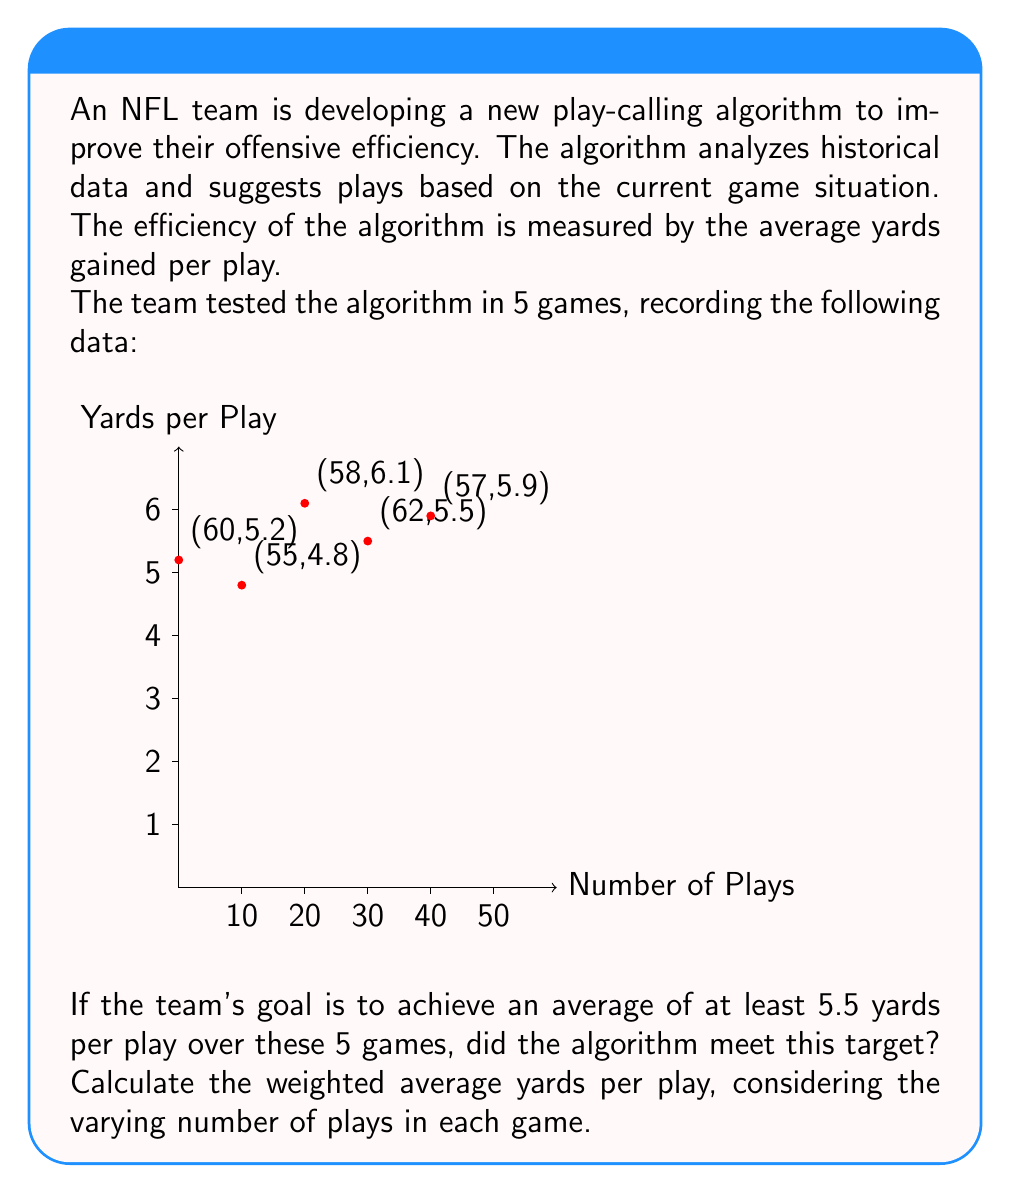Show me your answer to this math problem. To solve this problem, we need to calculate the weighted average of yards per play across all 5 games. The weight for each game is the number of plays in that game.

Step 1: Calculate the total yards gained in each game.
Game 1: $60 \times 5.2 = 312$ yards
Game 2: $55 \times 4.8 = 264$ yards
Game 3: $58 \times 6.1 = 353.8$ yards
Game 4: $62 \times 5.5 = 341$ yards
Game 5: $57 \times 5.9 = 336.3$ yards

Step 2: Sum up the total yards from all games.
Total yards = $312 + 264 + 353.8 + 341 + 336.3 = 1607.1$ yards

Step 3: Calculate the total number of plays across all games.
Total plays = $60 + 55 + 58 + 62 + 57 = 292$ plays

Step 4: Calculate the weighted average yards per play.
Weighted average = $\frac{\text{Total yards}}{\text{Total plays}} = \frac{1607.1}{292} \approx 5.504$ yards per play

Step 5: Compare the result to the target of 5.5 yards per play.
$5.504 < 5.5$

Therefore, the algorithm did not meet the target of 5.5 yards per play, but it was very close.
Answer: No, 5.504 yards/play 